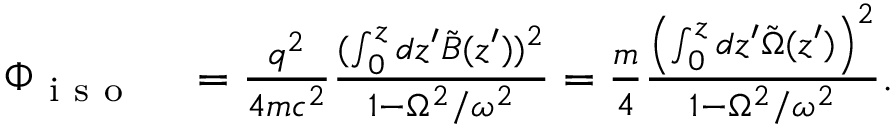<formula> <loc_0><loc_0><loc_500><loc_500>\begin{array} { r l } { \Phi _ { i s o } } & = \frac { q ^ { 2 } } { 4 m c ^ { 2 } } \frac { ( \int _ { 0 } ^ { z } d z ^ { \prime } \tilde { B } ( z ^ { \prime } ) ) ^ { 2 } } { 1 - \Omega ^ { 2 } / \omega ^ { 2 } } = \frac { m } { 4 } \frac { \left ( \int _ { 0 } ^ { z } d z ^ { \prime } \tilde { \Omega } ( z ^ { \prime } ) \right ) ^ { 2 } } { 1 - \Omega ^ { 2 } / \omega ^ { 2 } } . } \end{array}</formula> 